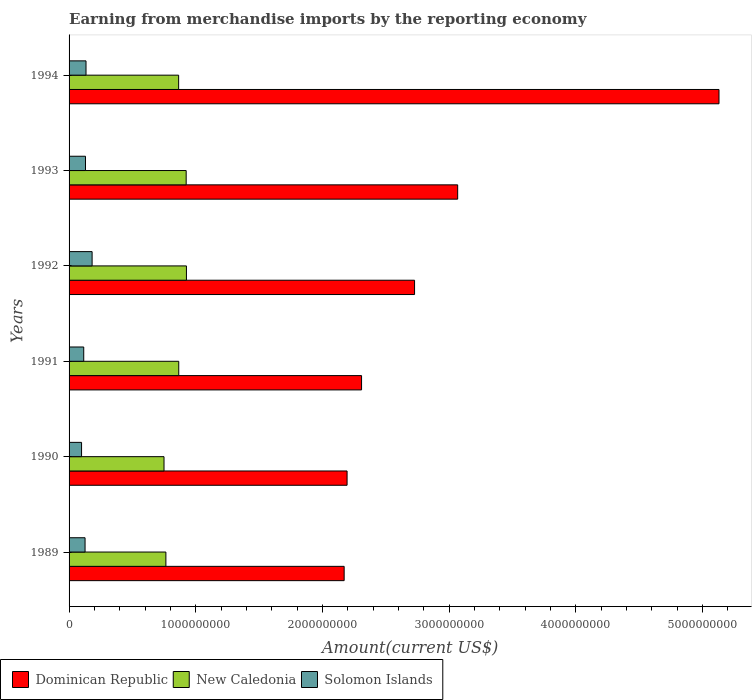How many groups of bars are there?
Offer a terse response. 6. Are the number of bars on each tick of the Y-axis equal?
Offer a very short reply. Yes. How many bars are there on the 3rd tick from the top?
Your response must be concise. 3. How many bars are there on the 2nd tick from the bottom?
Provide a succinct answer. 3. What is the label of the 2nd group of bars from the top?
Ensure brevity in your answer.  1993. What is the amount earned from merchandise imports in Solomon Islands in 1992?
Offer a very short reply. 1.82e+08. Across all years, what is the maximum amount earned from merchandise imports in Dominican Republic?
Your answer should be very brief. 5.13e+09. Across all years, what is the minimum amount earned from merchandise imports in Solomon Islands?
Keep it short and to the point. 9.86e+07. In which year was the amount earned from merchandise imports in Dominican Republic maximum?
Your response must be concise. 1994. What is the total amount earned from merchandise imports in New Caledonia in the graph?
Your answer should be compact. 5.09e+09. What is the difference between the amount earned from merchandise imports in New Caledonia in 1990 and that in 1992?
Offer a terse response. -1.77e+08. What is the difference between the amount earned from merchandise imports in Dominican Republic in 1994 and the amount earned from merchandise imports in New Caledonia in 1991?
Keep it short and to the point. 4.26e+09. What is the average amount earned from merchandise imports in New Caledonia per year?
Provide a succinct answer. 8.49e+08. In the year 1991, what is the difference between the amount earned from merchandise imports in Solomon Islands and amount earned from merchandise imports in New Caledonia?
Give a very brief answer. -7.50e+08. What is the ratio of the amount earned from merchandise imports in New Caledonia in 1990 to that in 1993?
Ensure brevity in your answer.  0.81. What is the difference between the highest and the second highest amount earned from merchandise imports in New Caledonia?
Your answer should be compact. 2.08e+06. What is the difference between the highest and the lowest amount earned from merchandise imports in Solomon Islands?
Make the answer very short. 8.32e+07. In how many years, is the amount earned from merchandise imports in Dominican Republic greater than the average amount earned from merchandise imports in Dominican Republic taken over all years?
Your answer should be compact. 2. What does the 3rd bar from the top in 1991 represents?
Give a very brief answer. Dominican Republic. What does the 1st bar from the bottom in 1993 represents?
Provide a short and direct response. Dominican Republic. Is it the case that in every year, the sum of the amount earned from merchandise imports in Solomon Islands and amount earned from merchandise imports in Dominican Republic is greater than the amount earned from merchandise imports in New Caledonia?
Provide a short and direct response. Yes. Are all the bars in the graph horizontal?
Your answer should be very brief. Yes. How many years are there in the graph?
Your answer should be very brief. 6. Are the values on the major ticks of X-axis written in scientific E-notation?
Keep it short and to the point. No. What is the title of the graph?
Keep it short and to the point. Earning from merchandise imports by the reporting economy. Does "Bangladesh" appear as one of the legend labels in the graph?
Keep it short and to the point. No. What is the label or title of the X-axis?
Your answer should be compact. Amount(current US$). What is the Amount(current US$) of Dominican Republic in 1989?
Provide a short and direct response. 2.17e+09. What is the Amount(current US$) in New Caledonia in 1989?
Your answer should be compact. 7.64e+08. What is the Amount(current US$) in Solomon Islands in 1989?
Your answer should be very brief. 1.26e+08. What is the Amount(current US$) of Dominican Republic in 1990?
Keep it short and to the point. 2.19e+09. What is the Amount(current US$) of New Caledonia in 1990?
Your answer should be very brief. 7.49e+08. What is the Amount(current US$) of Solomon Islands in 1990?
Keep it short and to the point. 9.86e+07. What is the Amount(current US$) in Dominican Republic in 1991?
Ensure brevity in your answer.  2.31e+09. What is the Amount(current US$) in New Caledonia in 1991?
Make the answer very short. 8.66e+08. What is the Amount(current US$) in Solomon Islands in 1991?
Provide a succinct answer. 1.16e+08. What is the Amount(current US$) of Dominican Republic in 1992?
Keep it short and to the point. 2.73e+09. What is the Amount(current US$) in New Caledonia in 1992?
Your answer should be very brief. 9.26e+08. What is the Amount(current US$) of Solomon Islands in 1992?
Your answer should be compact. 1.82e+08. What is the Amount(current US$) in Dominican Republic in 1993?
Your answer should be compact. 3.07e+09. What is the Amount(current US$) in New Caledonia in 1993?
Ensure brevity in your answer.  9.24e+08. What is the Amount(current US$) in Solomon Islands in 1993?
Your answer should be compact. 1.30e+08. What is the Amount(current US$) in Dominican Republic in 1994?
Your answer should be compact. 5.13e+09. What is the Amount(current US$) in New Caledonia in 1994?
Ensure brevity in your answer.  8.65e+08. What is the Amount(current US$) of Solomon Islands in 1994?
Make the answer very short. 1.34e+08. Across all years, what is the maximum Amount(current US$) of Dominican Republic?
Ensure brevity in your answer.  5.13e+09. Across all years, what is the maximum Amount(current US$) in New Caledonia?
Give a very brief answer. 9.26e+08. Across all years, what is the maximum Amount(current US$) of Solomon Islands?
Ensure brevity in your answer.  1.82e+08. Across all years, what is the minimum Amount(current US$) in Dominican Republic?
Keep it short and to the point. 2.17e+09. Across all years, what is the minimum Amount(current US$) of New Caledonia?
Your answer should be compact. 7.49e+08. Across all years, what is the minimum Amount(current US$) in Solomon Islands?
Give a very brief answer. 9.86e+07. What is the total Amount(current US$) of Dominican Republic in the graph?
Make the answer very short. 1.76e+1. What is the total Amount(current US$) of New Caledonia in the graph?
Your answer should be compact. 5.09e+09. What is the total Amount(current US$) in Solomon Islands in the graph?
Provide a short and direct response. 7.86e+08. What is the difference between the Amount(current US$) of Dominican Republic in 1989 and that in 1990?
Ensure brevity in your answer.  -2.31e+07. What is the difference between the Amount(current US$) of New Caledonia in 1989 and that in 1990?
Make the answer very short. 1.47e+07. What is the difference between the Amount(current US$) of Solomon Islands in 1989 and that in 1990?
Provide a succinct answer. 2.75e+07. What is the difference between the Amount(current US$) in Dominican Republic in 1989 and that in 1991?
Offer a very short reply. -1.37e+08. What is the difference between the Amount(current US$) of New Caledonia in 1989 and that in 1991?
Your answer should be compact. -1.02e+08. What is the difference between the Amount(current US$) of Solomon Islands in 1989 and that in 1991?
Provide a succinct answer. 1.05e+07. What is the difference between the Amount(current US$) in Dominican Republic in 1989 and that in 1992?
Your answer should be very brief. -5.56e+08. What is the difference between the Amount(current US$) of New Caledonia in 1989 and that in 1992?
Make the answer very short. -1.62e+08. What is the difference between the Amount(current US$) of Solomon Islands in 1989 and that in 1992?
Your answer should be compact. -5.57e+07. What is the difference between the Amount(current US$) in Dominican Republic in 1989 and that in 1993?
Provide a succinct answer. -8.96e+08. What is the difference between the Amount(current US$) in New Caledonia in 1989 and that in 1993?
Give a very brief answer. -1.60e+08. What is the difference between the Amount(current US$) in Solomon Islands in 1989 and that in 1993?
Offer a terse response. -3.37e+06. What is the difference between the Amount(current US$) in Dominican Republic in 1989 and that in 1994?
Your answer should be compact. -2.96e+09. What is the difference between the Amount(current US$) of New Caledonia in 1989 and that in 1994?
Offer a terse response. -1.01e+08. What is the difference between the Amount(current US$) of Solomon Islands in 1989 and that in 1994?
Make the answer very short. -7.59e+06. What is the difference between the Amount(current US$) in Dominican Republic in 1990 and that in 1991?
Offer a very short reply. -1.14e+08. What is the difference between the Amount(current US$) in New Caledonia in 1990 and that in 1991?
Your answer should be very brief. -1.16e+08. What is the difference between the Amount(current US$) of Solomon Islands in 1990 and that in 1991?
Offer a very short reply. -1.71e+07. What is the difference between the Amount(current US$) in Dominican Republic in 1990 and that in 1992?
Your answer should be very brief. -5.33e+08. What is the difference between the Amount(current US$) in New Caledonia in 1990 and that in 1992?
Your answer should be compact. -1.77e+08. What is the difference between the Amount(current US$) in Solomon Islands in 1990 and that in 1992?
Keep it short and to the point. -8.32e+07. What is the difference between the Amount(current US$) of Dominican Republic in 1990 and that in 1993?
Make the answer very short. -8.73e+08. What is the difference between the Amount(current US$) of New Caledonia in 1990 and that in 1993?
Ensure brevity in your answer.  -1.75e+08. What is the difference between the Amount(current US$) in Solomon Islands in 1990 and that in 1993?
Your answer should be very brief. -3.09e+07. What is the difference between the Amount(current US$) of Dominican Republic in 1990 and that in 1994?
Provide a succinct answer. -2.94e+09. What is the difference between the Amount(current US$) of New Caledonia in 1990 and that in 1994?
Make the answer very short. -1.15e+08. What is the difference between the Amount(current US$) of Solomon Islands in 1990 and that in 1994?
Keep it short and to the point. -3.51e+07. What is the difference between the Amount(current US$) of Dominican Republic in 1991 and that in 1992?
Your answer should be compact. -4.18e+08. What is the difference between the Amount(current US$) in New Caledonia in 1991 and that in 1992?
Provide a short and direct response. -6.07e+07. What is the difference between the Amount(current US$) of Solomon Islands in 1991 and that in 1992?
Offer a very short reply. -6.62e+07. What is the difference between the Amount(current US$) of Dominican Republic in 1991 and that in 1993?
Offer a very short reply. -7.59e+08. What is the difference between the Amount(current US$) of New Caledonia in 1991 and that in 1993?
Provide a succinct answer. -5.86e+07. What is the difference between the Amount(current US$) in Solomon Islands in 1991 and that in 1993?
Offer a terse response. -1.39e+07. What is the difference between the Amount(current US$) in Dominican Republic in 1991 and that in 1994?
Your answer should be compact. -2.82e+09. What is the difference between the Amount(current US$) of New Caledonia in 1991 and that in 1994?
Your response must be concise. 8.07e+05. What is the difference between the Amount(current US$) of Solomon Islands in 1991 and that in 1994?
Make the answer very short. -1.81e+07. What is the difference between the Amount(current US$) in Dominican Republic in 1992 and that in 1993?
Your answer should be very brief. -3.40e+08. What is the difference between the Amount(current US$) of New Caledonia in 1992 and that in 1993?
Provide a succinct answer. 2.08e+06. What is the difference between the Amount(current US$) of Solomon Islands in 1992 and that in 1993?
Give a very brief answer. 5.23e+07. What is the difference between the Amount(current US$) of Dominican Republic in 1992 and that in 1994?
Offer a terse response. -2.40e+09. What is the difference between the Amount(current US$) in New Caledonia in 1992 and that in 1994?
Give a very brief answer. 6.15e+07. What is the difference between the Amount(current US$) in Solomon Islands in 1992 and that in 1994?
Ensure brevity in your answer.  4.81e+07. What is the difference between the Amount(current US$) in Dominican Republic in 1993 and that in 1994?
Provide a succinct answer. -2.06e+09. What is the difference between the Amount(current US$) of New Caledonia in 1993 and that in 1994?
Make the answer very short. 5.94e+07. What is the difference between the Amount(current US$) in Solomon Islands in 1993 and that in 1994?
Your response must be concise. -4.22e+06. What is the difference between the Amount(current US$) of Dominican Republic in 1989 and the Amount(current US$) of New Caledonia in 1990?
Provide a succinct answer. 1.42e+09. What is the difference between the Amount(current US$) of Dominican Republic in 1989 and the Amount(current US$) of Solomon Islands in 1990?
Make the answer very short. 2.07e+09. What is the difference between the Amount(current US$) in New Caledonia in 1989 and the Amount(current US$) in Solomon Islands in 1990?
Your response must be concise. 6.65e+08. What is the difference between the Amount(current US$) in Dominican Republic in 1989 and the Amount(current US$) in New Caledonia in 1991?
Offer a terse response. 1.31e+09. What is the difference between the Amount(current US$) in Dominican Republic in 1989 and the Amount(current US$) in Solomon Islands in 1991?
Your response must be concise. 2.06e+09. What is the difference between the Amount(current US$) in New Caledonia in 1989 and the Amount(current US$) in Solomon Islands in 1991?
Keep it short and to the point. 6.48e+08. What is the difference between the Amount(current US$) of Dominican Republic in 1989 and the Amount(current US$) of New Caledonia in 1992?
Keep it short and to the point. 1.24e+09. What is the difference between the Amount(current US$) in Dominican Republic in 1989 and the Amount(current US$) in Solomon Islands in 1992?
Offer a terse response. 1.99e+09. What is the difference between the Amount(current US$) in New Caledonia in 1989 and the Amount(current US$) in Solomon Islands in 1992?
Keep it short and to the point. 5.82e+08. What is the difference between the Amount(current US$) of Dominican Republic in 1989 and the Amount(current US$) of New Caledonia in 1993?
Offer a very short reply. 1.25e+09. What is the difference between the Amount(current US$) in Dominican Republic in 1989 and the Amount(current US$) in Solomon Islands in 1993?
Keep it short and to the point. 2.04e+09. What is the difference between the Amount(current US$) in New Caledonia in 1989 and the Amount(current US$) in Solomon Islands in 1993?
Provide a succinct answer. 6.35e+08. What is the difference between the Amount(current US$) in Dominican Republic in 1989 and the Amount(current US$) in New Caledonia in 1994?
Offer a terse response. 1.31e+09. What is the difference between the Amount(current US$) in Dominican Republic in 1989 and the Amount(current US$) in Solomon Islands in 1994?
Keep it short and to the point. 2.04e+09. What is the difference between the Amount(current US$) of New Caledonia in 1989 and the Amount(current US$) of Solomon Islands in 1994?
Your answer should be compact. 6.30e+08. What is the difference between the Amount(current US$) in Dominican Republic in 1990 and the Amount(current US$) in New Caledonia in 1991?
Your answer should be very brief. 1.33e+09. What is the difference between the Amount(current US$) in Dominican Republic in 1990 and the Amount(current US$) in Solomon Islands in 1991?
Your answer should be compact. 2.08e+09. What is the difference between the Amount(current US$) in New Caledonia in 1990 and the Amount(current US$) in Solomon Islands in 1991?
Provide a succinct answer. 6.34e+08. What is the difference between the Amount(current US$) of Dominican Republic in 1990 and the Amount(current US$) of New Caledonia in 1992?
Your response must be concise. 1.27e+09. What is the difference between the Amount(current US$) of Dominican Republic in 1990 and the Amount(current US$) of Solomon Islands in 1992?
Keep it short and to the point. 2.01e+09. What is the difference between the Amount(current US$) of New Caledonia in 1990 and the Amount(current US$) of Solomon Islands in 1992?
Your answer should be compact. 5.68e+08. What is the difference between the Amount(current US$) of Dominican Republic in 1990 and the Amount(current US$) of New Caledonia in 1993?
Offer a very short reply. 1.27e+09. What is the difference between the Amount(current US$) of Dominican Republic in 1990 and the Amount(current US$) of Solomon Islands in 1993?
Your answer should be compact. 2.06e+09. What is the difference between the Amount(current US$) of New Caledonia in 1990 and the Amount(current US$) of Solomon Islands in 1993?
Provide a short and direct response. 6.20e+08. What is the difference between the Amount(current US$) of Dominican Republic in 1990 and the Amount(current US$) of New Caledonia in 1994?
Give a very brief answer. 1.33e+09. What is the difference between the Amount(current US$) in Dominican Republic in 1990 and the Amount(current US$) in Solomon Islands in 1994?
Make the answer very short. 2.06e+09. What is the difference between the Amount(current US$) of New Caledonia in 1990 and the Amount(current US$) of Solomon Islands in 1994?
Make the answer very short. 6.16e+08. What is the difference between the Amount(current US$) of Dominican Republic in 1991 and the Amount(current US$) of New Caledonia in 1992?
Keep it short and to the point. 1.38e+09. What is the difference between the Amount(current US$) of Dominican Republic in 1991 and the Amount(current US$) of Solomon Islands in 1992?
Ensure brevity in your answer.  2.13e+09. What is the difference between the Amount(current US$) in New Caledonia in 1991 and the Amount(current US$) in Solomon Islands in 1992?
Provide a short and direct response. 6.84e+08. What is the difference between the Amount(current US$) in Dominican Republic in 1991 and the Amount(current US$) in New Caledonia in 1993?
Ensure brevity in your answer.  1.38e+09. What is the difference between the Amount(current US$) in Dominican Republic in 1991 and the Amount(current US$) in Solomon Islands in 1993?
Offer a very short reply. 2.18e+09. What is the difference between the Amount(current US$) in New Caledonia in 1991 and the Amount(current US$) in Solomon Islands in 1993?
Offer a very short reply. 7.36e+08. What is the difference between the Amount(current US$) in Dominican Republic in 1991 and the Amount(current US$) in New Caledonia in 1994?
Offer a terse response. 1.44e+09. What is the difference between the Amount(current US$) of Dominican Republic in 1991 and the Amount(current US$) of Solomon Islands in 1994?
Offer a terse response. 2.17e+09. What is the difference between the Amount(current US$) of New Caledonia in 1991 and the Amount(current US$) of Solomon Islands in 1994?
Offer a very short reply. 7.32e+08. What is the difference between the Amount(current US$) of Dominican Republic in 1992 and the Amount(current US$) of New Caledonia in 1993?
Your answer should be very brief. 1.80e+09. What is the difference between the Amount(current US$) in Dominican Republic in 1992 and the Amount(current US$) in Solomon Islands in 1993?
Your answer should be very brief. 2.60e+09. What is the difference between the Amount(current US$) in New Caledonia in 1992 and the Amount(current US$) in Solomon Islands in 1993?
Make the answer very short. 7.97e+08. What is the difference between the Amount(current US$) of Dominican Republic in 1992 and the Amount(current US$) of New Caledonia in 1994?
Your response must be concise. 1.86e+09. What is the difference between the Amount(current US$) of Dominican Republic in 1992 and the Amount(current US$) of Solomon Islands in 1994?
Your response must be concise. 2.59e+09. What is the difference between the Amount(current US$) in New Caledonia in 1992 and the Amount(current US$) in Solomon Islands in 1994?
Keep it short and to the point. 7.93e+08. What is the difference between the Amount(current US$) of Dominican Republic in 1993 and the Amount(current US$) of New Caledonia in 1994?
Keep it short and to the point. 2.20e+09. What is the difference between the Amount(current US$) in Dominican Republic in 1993 and the Amount(current US$) in Solomon Islands in 1994?
Provide a short and direct response. 2.93e+09. What is the difference between the Amount(current US$) of New Caledonia in 1993 and the Amount(current US$) of Solomon Islands in 1994?
Provide a short and direct response. 7.90e+08. What is the average Amount(current US$) of Dominican Republic per year?
Your answer should be compact. 2.93e+09. What is the average Amount(current US$) in New Caledonia per year?
Ensure brevity in your answer.  8.49e+08. What is the average Amount(current US$) in Solomon Islands per year?
Offer a very short reply. 1.31e+08. In the year 1989, what is the difference between the Amount(current US$) in Dominican Republic and Amount(current US$) in New Caledonia?
Keep it short and to the point. 1.41e+09. In the year 1989, what is the difference between the Amount(current US$) in Dominican Republic and Amount(current US$) in Solomon Islands?
Give a very brief answer. 2.04e+09. In the year 1989, what is the difference between the Amount(current US$) of New Caledonia and Amount(current US$) of Solomon Islands?
Keep it short and to the point. 6.38e+08. In the year 1990, what is the difference between the Amount(current US$) of Dominican Republic and Amount(current US$) of New Caledonia?
Offer a terse response. 1.44e+09. In the year 1990, what is the difference between the Amount(current US$) in Dominican Republic and Amount(current US$) in Solomon Islands?
Your response must be concise. 2.10e+09. In the year 1990, what is the difference between the Amount(current US$) of New Caledonia and Amount(current US$) of Solomon Islands?
Make the answer very short. 6.51e+08. In the year 1991, what is the difference between the Amount(current US$) in Dominican Republic and Amount(current US$) in New Caledonia?
Your answer should be compact. 1.44e+09. In the year 1991, what is the difference between the Amount(current US$) of Dominican Republic and Amount(current US$) of Solomon Islands?
Keep it short and to the point. 2.19e+09. In the year 1991, what is the difference between the Amount(current US$) in New Caledonia and Amount(current US$) in Solomon Islands?
Make the answer very short. 7.50e+08. In the year 1992, what is the difference between the Amount(current US$) in Dominican Republic and Amount(current US$) in New Caledonia?
Your answer should be compact. 1.80e+09. In the year 1992, what is the difference between the Amount(current US$) in Dominican Republic and Amount(current US$) in Solomon Islands?
Your response must be concise. 2.54e+09. In the year 1992, what is the difference between the Amount(current US$) in New Caledonia and Amount(current US$) in Solomon Islands?
Your response must be concise. 7.44e+08. In the year 1993, what is the difference between the Amount(current US$) in Dominican Republic and Amount(current US$) in New Caledonia?
Provide a succinct answer. 2.14e+09. In the year 1993, what is the difference between the Amount(current US$) in Dominican Republic and Amount(current US$) in Solomon Islands?
Ensure brevity in your answer.  2.94e+09. In the year 1993, what is the difference between the Amount(current US$) of New Caledonia and Amount(current US$) of Solomon Islands?
Give a very brief answer. 7.95e+08. In the year 1994, what is the difference between the Amount(current US$) in Dominican Republic and Amount(current US$) in New Caledonia?
Provide a succinct answer. 4.26e+09. In the year 1994, what is the difference between the Amount(current US$) in Dominican Republic and Amount(current US$) in Solomon Islands?
Offer a terse response. 5.00e+09. In the year 1994, what is the difference between the Amount(current US$) of New Caledonia and Amount(current US$) of Solomon Islands?
Keep it short and to the point. 7.31e+08. What is the ratio of the Amount(current US$) of Dominican Republic in 1989 to that in 1990?
Ensure brevity in your answer.  0.99. What is the ratio of the Amount(current US$) of New Caledonia in 1989 to that in 1990?
Keep it short and to the point. 1.02. What is the ratio of the Amount(current US$) of Solomon Islands in 1989 to that in 1990?
Ensure brevity in your answer.  1.28. What is the ratio of the Amount(current US$) of Dominican Republic in 1989 to that in 1991?
Offer a terse response. 0.94. What is the ratio of the Amount(current US$) in New Caledonia in 1989 to that in 1991?
Provide a succinct answer. 0.88. What is the ratio of the Amount(current US$) in Solomon Islands in 1989 to that in 1991?
Offer a very short reply. 1.09. What is the ratio of the Amount(current US$) of Dominican Republic in 1989 to that in 1992?
Offer a terse response. 0.8. What is the ratio of the Amount(current US$) of New Caledonia in 1989 to that in 1992?
Give a very brief answer. 0.82. What is the ratio of the Amount(current US$) of Solomon Islands in 1989 to that in 1992?
Offer a very short reply. 0.69. What is the ratio of the Amount(current US$) of Dominican Republic in 1989 to that in 1993?
Ensure brevity in your answer.  0.71. What is the ratio of the Amount(current US$) of New Caledonia in 1989 to that in 1993?
Your answer should be compact. 0.83. What is the ratio of the Amount(current US$) of Solomon Islands in 1989 to that in 1993?
Offer a terse response. 0.97. What is the ratio of the Amount(current US$) in Dominican Republic in 1989 to that in 1994?
Provide a short and direct response. 0.42. What is the ratio of the Amount(current US$) of New Caledonia in 1989 to that in 1994?
Ensure brevity in your answer.  0.88. What is the ratio of the Amount(current US$) in Solomon Islands in 1989 to that in 1994?
Ensure brevity in your answer.  0.94. What is the ratio of the Amount(current US$) in Dominican Republic in 1990 to that in 1991?
Give a very brief answer. 0.95. What is the ratio of the Amount(current US$) of New Caledonia in 1990 to that in 1991?
Offer a very short reply. 0.87. What is the ratio of the Amount(current US$) in Solomon Islands in 1990 to that in 1991?
Make the answer very short. 0.85. What is the ratio of the Amount(current US$) in Dominican Republic in 1990 to that in 1992?
Your answer should be compact. 0.8. What is the ratio of the Amount(current US$) in New Caledonia in 1990 to that in 1992?
Make the answer very short. 0.81. What is the ratio of the Amount(current US$) in Solomon Islands in 1990 to that in 1992?
Provide a short and direct response. 0.54. What is the ratio of the Amount(current US$) of Dominican Republic in 1990 to that in 1993?
Offer a very short reply. 0.72. What is the ratio of the Amount(current US$) in New Caledonia in 1990 to that in 1993?
Ensure brevity in your answer.  0.81. What is the ratio of the Amount(current US$) in Solomon Islands in 1990 to that in 1993?
Offer a very short reply. 0.76. What is the ratio of the Amount(current US$) of Dominican Republic in 1990 to that in 1994?
Keep it short and to the point. 0.43. What is the ratio of the Amount(current US$) in New Caledonia in 1990 to that in 1994?
Offer a very short reply. 0.87. What is the ratio of the Amount(current US$) in Solomon Islands in 1990 to that in 1994?
Make the answer very short. 0.74. What is the ratio of the Amount(current US$) in Dominican Republic in 1991 to that in 1992?
Your answer should be very brief. 0.85. What is the ratio of the Amount(current US$) in New Caledonia in 1991 to that in 1992?
Your response must be concise. 0.93. What is the ratio of the Amount(current US$) in Solomon Islands in 1991 to that in 1992?
Your answer should be compact. 0.64. What is the ratio of the Amount(current US$) of Dominican Republic in 1991 to that in 1993?
Make the answer very short. 0.75. What is the ratio of the Amount(current US$) in New Caledonia in 1991 to that in 1993?
Your answer should be very brief. 0.94. What is the ratio of the Amount(current US$) in Solomon Islands in 1991 to that in 1993?
Your answer should be compact. 0.89. What is the ratio of the Amount(current US$) in Dominican Republic in 1991 to that in 1994?
Offer a very short reply. 0.45. What is the ratio of the Amount(current US$) of New Caledonia in 1991 to that in 1994?
Ensure brevity in your answer.  1. What is the ratio of the Amount(current US$) of Solomon Islands in 1991 to that in 1994?
Your response must be concise. 0.86. What is the ratio of the Amount(current US$) of Dominican Republic in 1992 to that in 1993?
Keep it short and to the point. 0.89. What is the ratio of the Amount(current US$) in Solomon Islands in 1992 to that in 1993?
Make the answer very short. 1.4. What is the ratio of the Amount(current US$) in Dominican Republic in 1992 to that in 1994?
Your response must be concise. 0.53. What is the ratio of the Amount(current US$) in New Caledonia in 1992 to that in 1994?
Offer a very short reply. 1.07. What is the ratio of the Amount(current US$) of Solomon Islands in 1992 to that in 1994?
Your answer should be very brief. 1.36. What is the ratio of the Amount(current US$) in Dominican Republic in 1993 to that in 1994?
Keep it short and to the point. 0.6. What is the ratio of the Amount(current US$) in New Caledonia in 1993 to that in 1994?
Provide a succinct answer. 1.07. What is the ratio of the Amount(current US$) in Solomon Islands in 1993 to that in 1994?
Offer a terse response. 0.97. What is the difference between the highest and the second highest Amount(current US$) in Dominican Republic?
Make the answer very short. 2.06e+09. What is the difference between the highest and the second highest Amount(current US$) in New Caledonia?
Offer a very short reply. 2.08e+06. What is the difference between the highest and the second highest Amount(current US$) in Solomon Islands?
Your response must be concise. 4.81e+07. What is the difference between the highest and the lowest Amount(current US$) of Dominican Republic?
Your response must be concise. 2.96e+09. What is the difference between the highest and the lowest Amount(current US$) of New Caledonia?
Provide a succinct answer. 1.77e+08. What is the difference between the highest and the lowest Amount(current US$) in Solomon Islands?
Provide a short and direct response. 8.32e+07. 